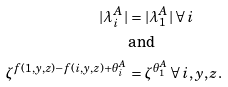<formula> <loc_0><loc_0><loc_500><loc_500>| \lambda ^ { A } _ { i } | & = | \lambda ^ { A } _ { 1 } | \, \forall \, i \\ & \text {and} \\ \zeta ^ { f ( 1 , y , z ) - f ( i , y , z ) + \theta ^ { A } _ { i } } & = \zeta ^ { \theta ^ { A } _ { 1 } } \, \forall \, i , y , z .</formula> 